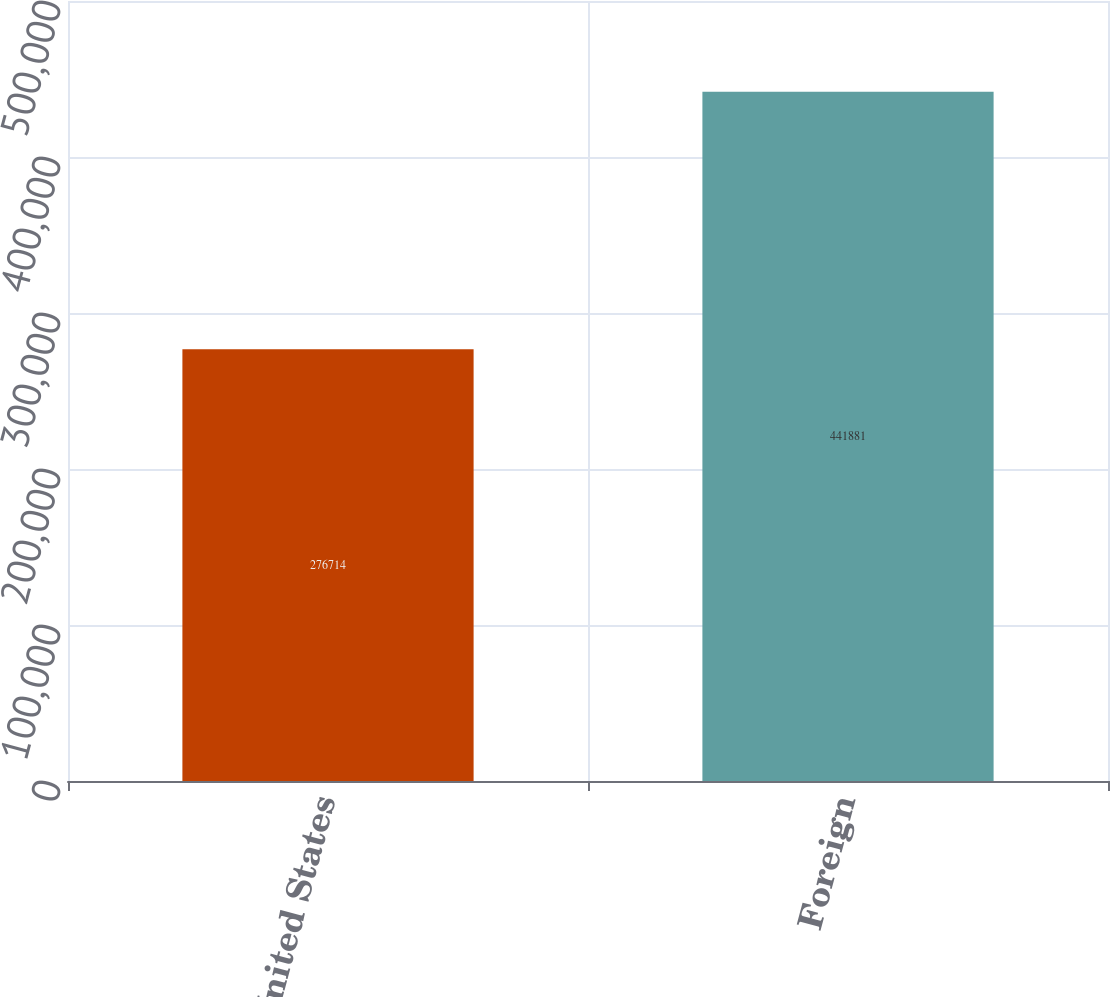Convert chart to OTSL. <chart><loc_0><loc_0><loc_500><loc_500><bar_chart><fcel>United States<fcel>Foreign<nl><fcel>276714<fcel>441881<nl></chart> 